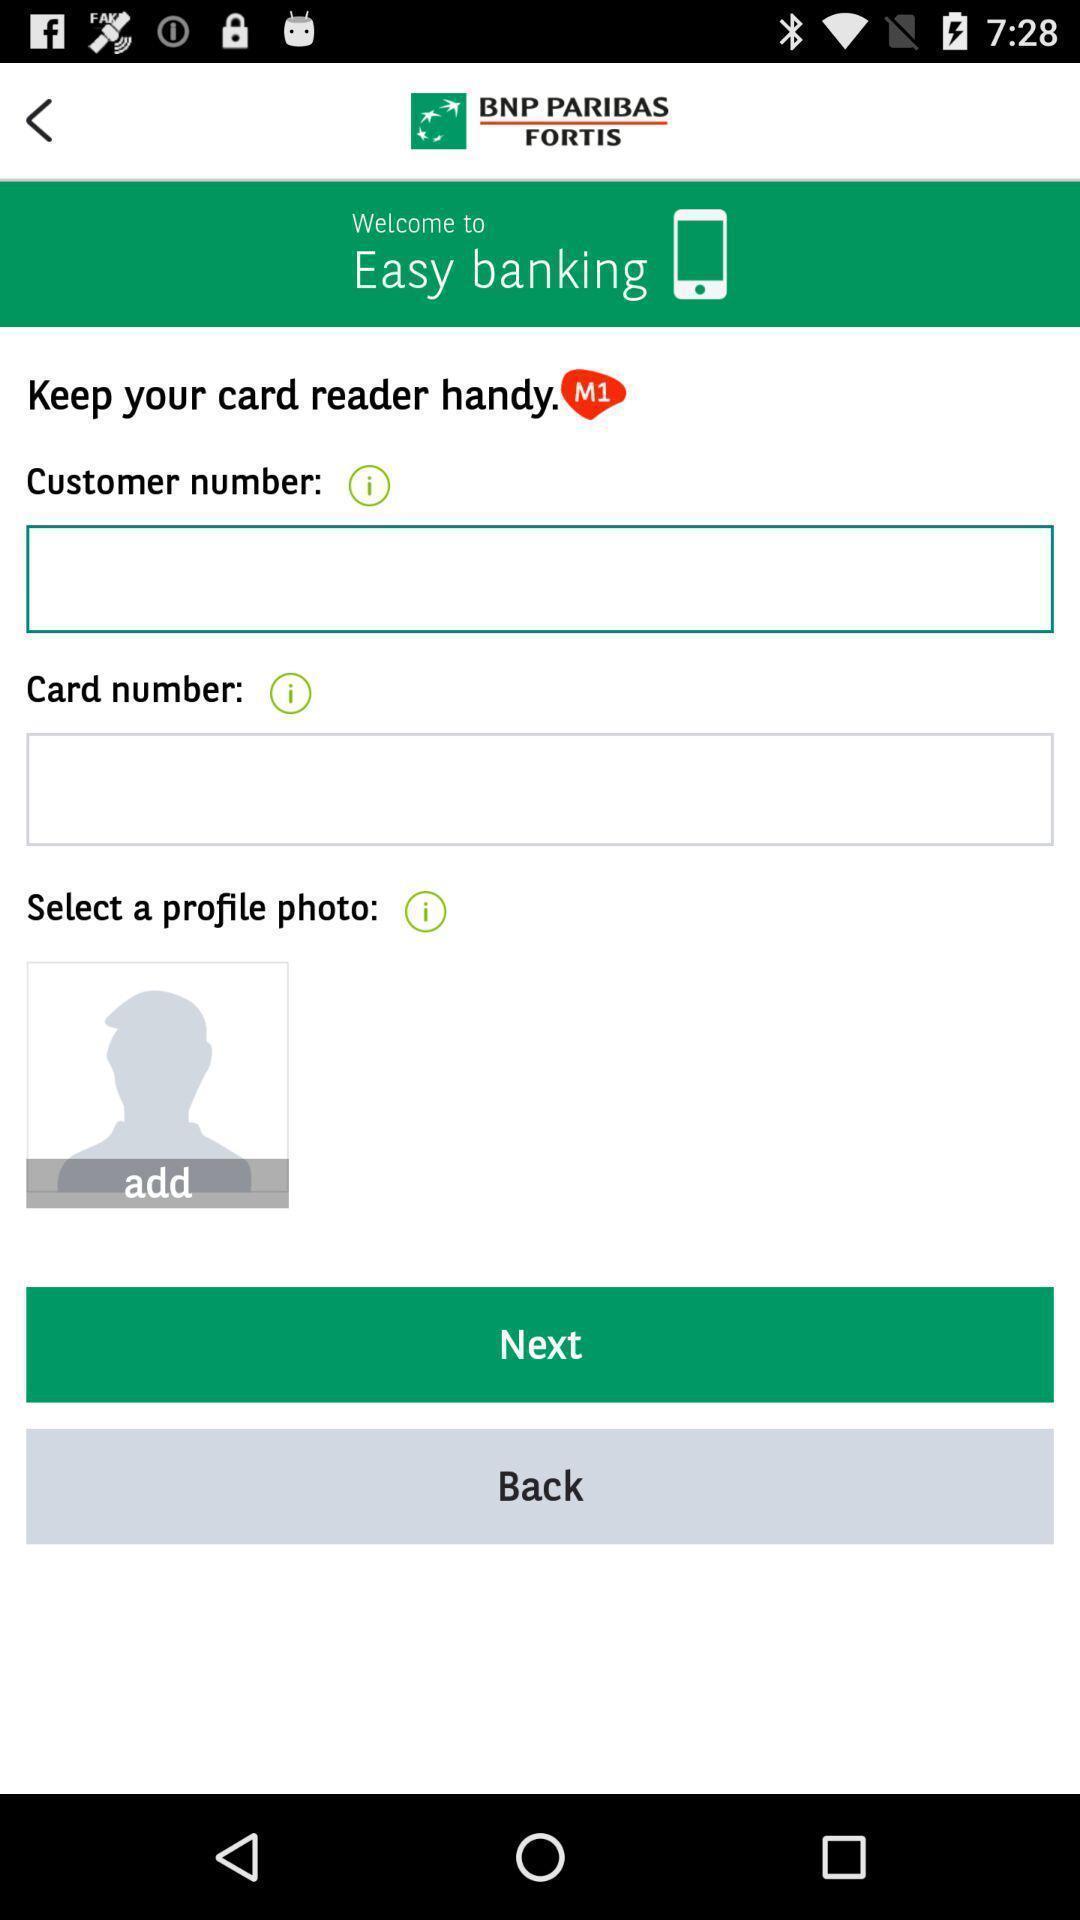Provide a textual representation of this image. Profile page of a banking app. 